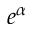Convert formula to latex. <formula><loc_0><loc_0><loc_500><loc_500>e ^ { \alpha }</formula> 